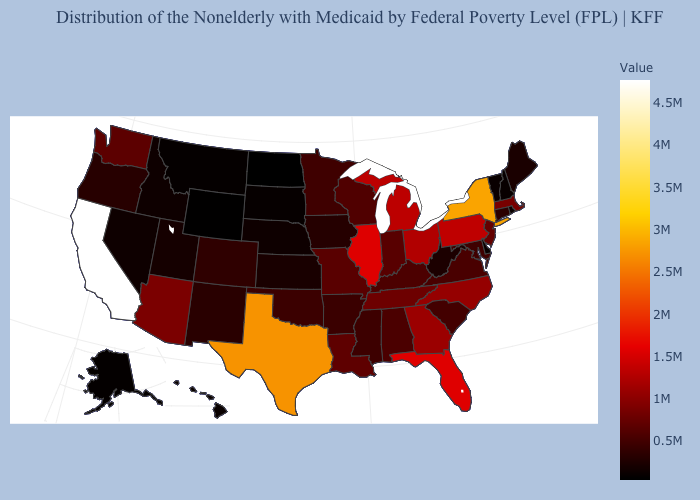Does Massachusetts have a higher value than Florida?
Be succinct. No. Which states have the highest value in the USA?
Quick response, please. California. Does the map have missing data?
Concise answer only. No. Among the states that border New Jersey , which have the lowest value?
Answer briefly. Delaware. 